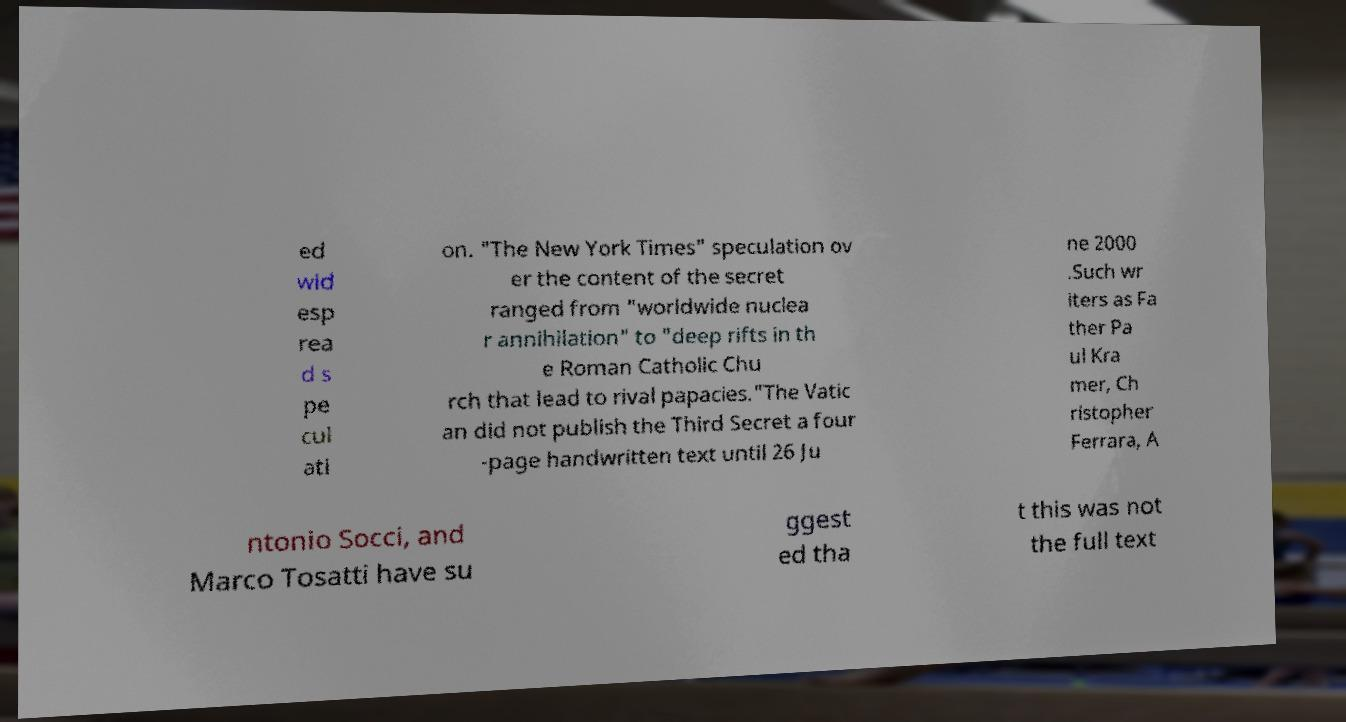Please identify and transcribe the text found in this image. ed wid esp rea d s pe cul ati on. "The New York Times" speculation ov er the content of the secret ranged from "worldwide nuclea r annihilation" to "deep rifts in th e Roman Catholic Chu rch that lead to rival papacies."The Vatic an did not publish the Third Secret a four -page handwritten text until 26 Ju ne 2000 .Such wr iters as Fa ther Pa ul Kra mer, Ch ristopher Ferrara, A ntonio Socci, and Marco Tosatti have su ggest ed tha t this was not the full text 